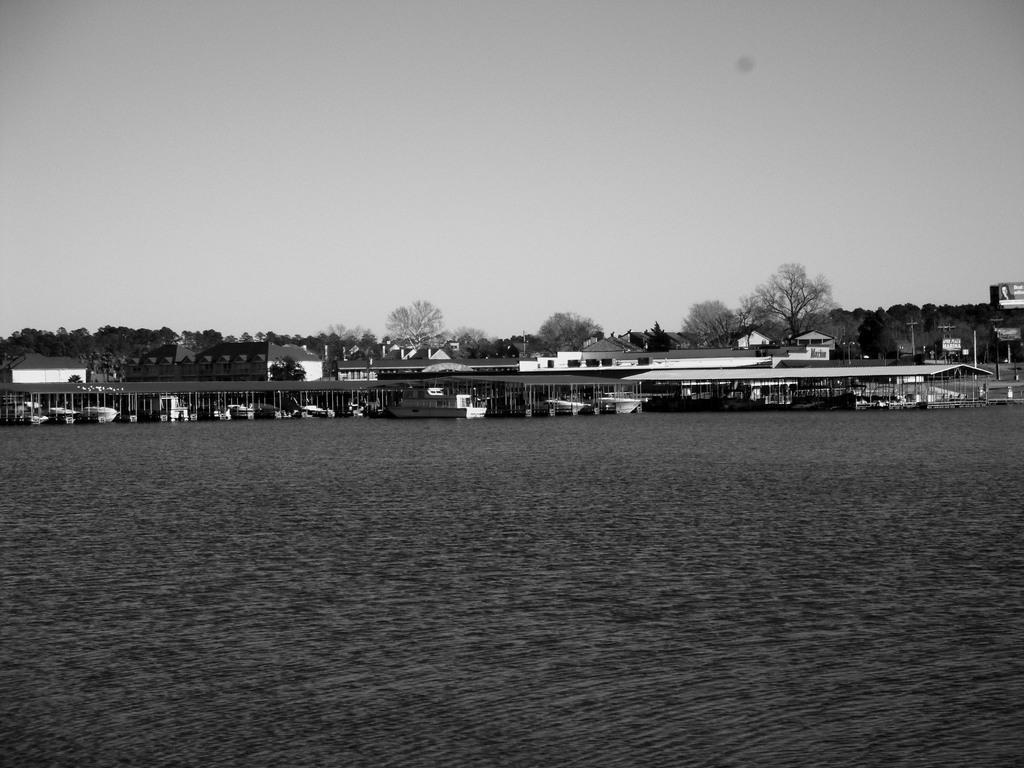Describe this image in one or two sentences. In this image we can able to see few houses on the sea shore, there are few boats, we can see some trees and sky. 